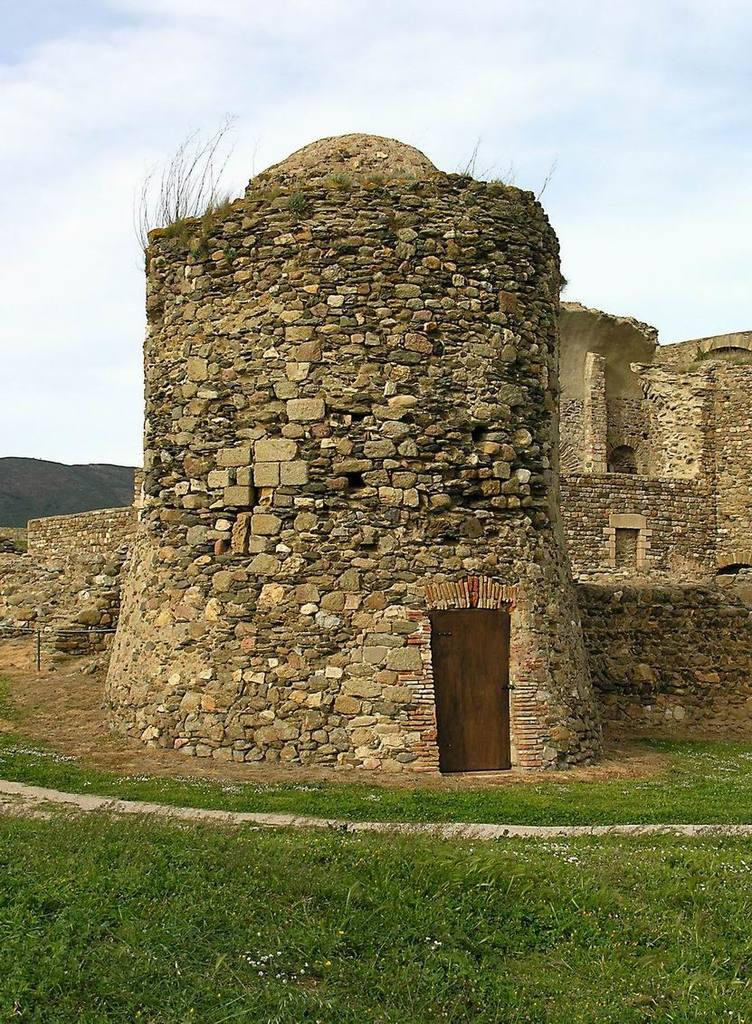What type of structure is in the image? There is a castle in the image. How is the castle built? The castle is constructed with stones. Can you describe the entrance to the castle? There is a door in the castle. What is visible at the bottom of the image? There is a lane and grass at the bottom of the image. What is visible at the top of the image? The sky is visible at the top of the image, and there are clouds in the sky. What type of chain can be seen hanging from the castle walls in the image? There is no chain hanging from the castle walls in the image. What color is the chalk used to draw on the grass in the image? There is no chalk or drawing on the grass in the image. 